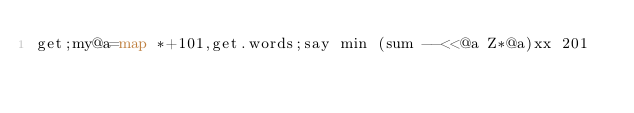Convert code to text. <code><loc_0><loc_0><loc_500><loc_500><_Perl_>get;my@a=map *+101,get.words;say min (sum --<<@a Z*@a)xx 201</code> 